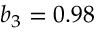Convert formula to latex. <formula><loc_0><loc_0><loc_500><loc_500>b _ { 3 } = 0 . 9 8</formula> 